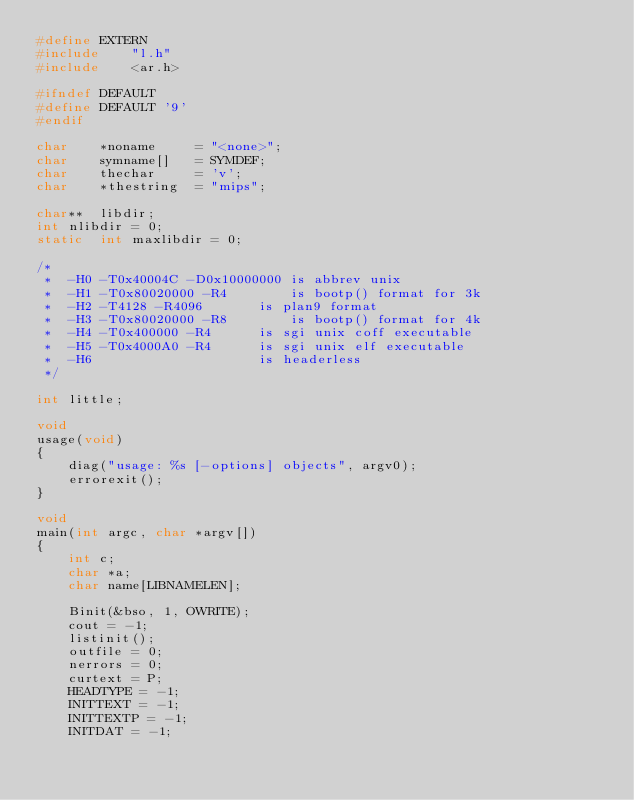Convert code to text. <code><loc_0><loc_0><loc_500><loc_500><_C_>#define	EXTERN
#include	"l.h"
#include	<ar.h>

#ifndef	DEFAULT
#define	DEFAULT	'9'
#endif

char	*noname		= "<none>";
char	symname[]	= SYMDEF;
char	thechar		= 'v';
char	*thestring 	= "mips";

char**	libdir;
int	nlibdir	= 0;
static	int	maxlibdir = 0;

/*
 *	-H0 -T0x40004C -D0x10000000	is abbrev unix
 *	-H1 -T0x80020000 -R4		is bootp() format for 3k
 *	-H2 -T4128 -R4096		is plan9 format
 *	-H3 -T0x80020000 -R8		is bootp() format for 4k
 *	-H4 -T0x400000 -R4		is sgi unix coff executable
 *	-H5 -T0x4000A0 -R4		is sgi unix elf executable
 *	-H6						is headerless
 */

int little;

void
usage(void)
{
	diag("usage: %s [-options] objects", argv0);
	errorexit();
}

void
main(int argc, char *argv[])
{
	int c;
	char *a;
	char name[LIBNAMELEN];

	Binit(&bso, 1, OWRITE);
	cout = -1;
	listinit();
	outfile = 0;
	nerrors = 0;
	curtext = P;
	HEADTYPE = -1;
	INITTEXT = -1;
	INITTEXTP = -1;
	INITDAT = -1;</code> 